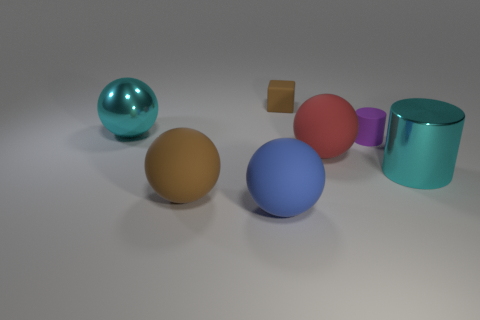Is the number of small brown rubber blocks that are in front of the red ball the same as the number of rubber things?
Your answer should be very brief. No. How many rubber things are in front of the big matte ball behind the big cyan metallic object that is on the right side of the blue thing?
Your answer should be very brief. 2. Is there another cyan cylinder that has the same size as the cyan metal cylinder?
Offer a terse response. No. Is the number of cyan shiny cylinders on the left side of the tiny block less than the number of large cyan metallic cylinders?
Provide a short and direct response. Yes. What is the material of the brown thing that is behind the big cyan thing that is right of the rubber ball that is to the left of the large blue sphere?
Your response must be concise. Rubber. Is the number of large red spheres that are in front of the tiny rubber block greater than the number of large brown rubber things that are behind the big red rubber object?
Give a very brief answer. Yes. How many matte objects are brown cubes or small purple cylinders?
Your answer should be very brief. 2. There is a large object that is the same color as the small block; what is its shape?
Your response must be concise. Sphere. What is the material of the brown thing in front of the tiny matte cylinder?
Provide a succinct answer. Rubber. What number of objects are either blue matte blocks or large balls that are behind the blue thing?
Your response must be concise. 3. 